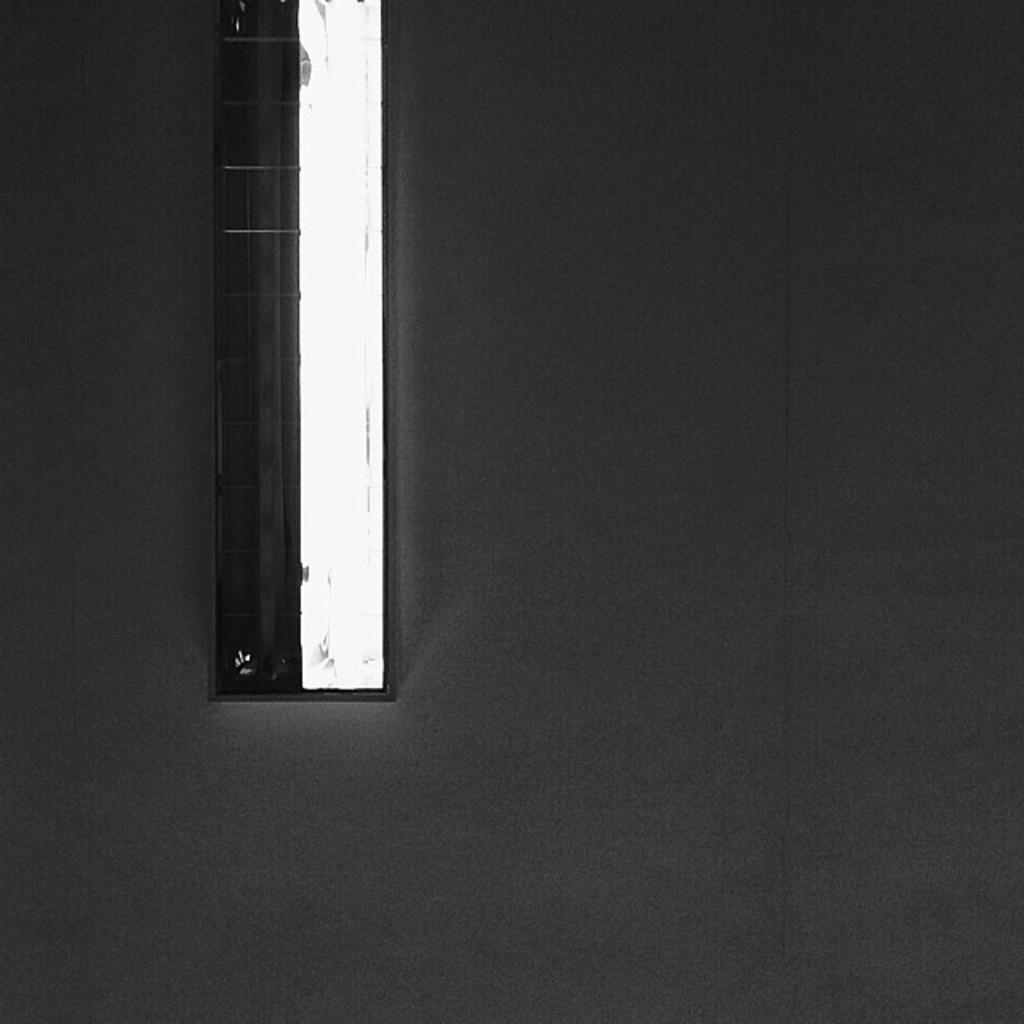What type of object in the image resembles a window? There is a window-like object in the image. What features does the window-like object have? The window-like object has a grill, a pipe, and glass. What color is the grey object in the image? There is a grey color object in the image. What type of crown is being worn by the trucks in the image? There are no trucks or crowns present in the image. 